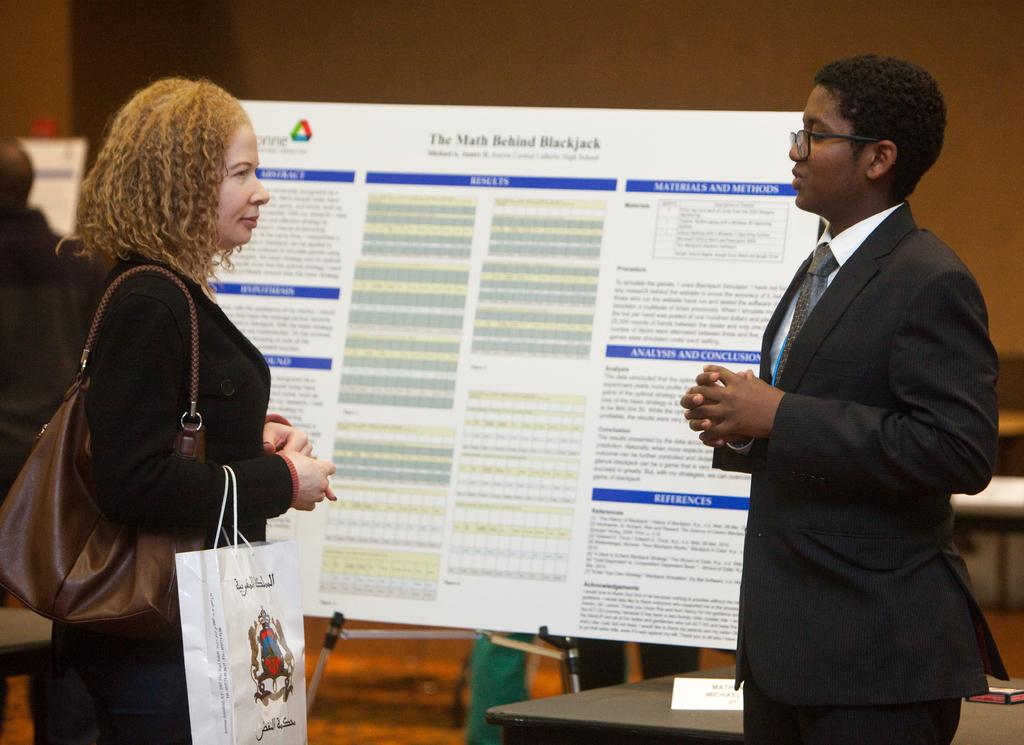How many women are in the image? There are women in the image. What are the women doing in the image? The women are standing on the ground. What is one of the women holding in the image? One of the women is holding a paper bag. What can be seen in the background of the image? There is an information board and walls in the background of the image. What type of drain can be seen in the image? There is no drain present in the image. What sound can be heard coming from the sky in the image? There is no sound mentioned or depicted in the image, so it cannot be determined what might be heard. 